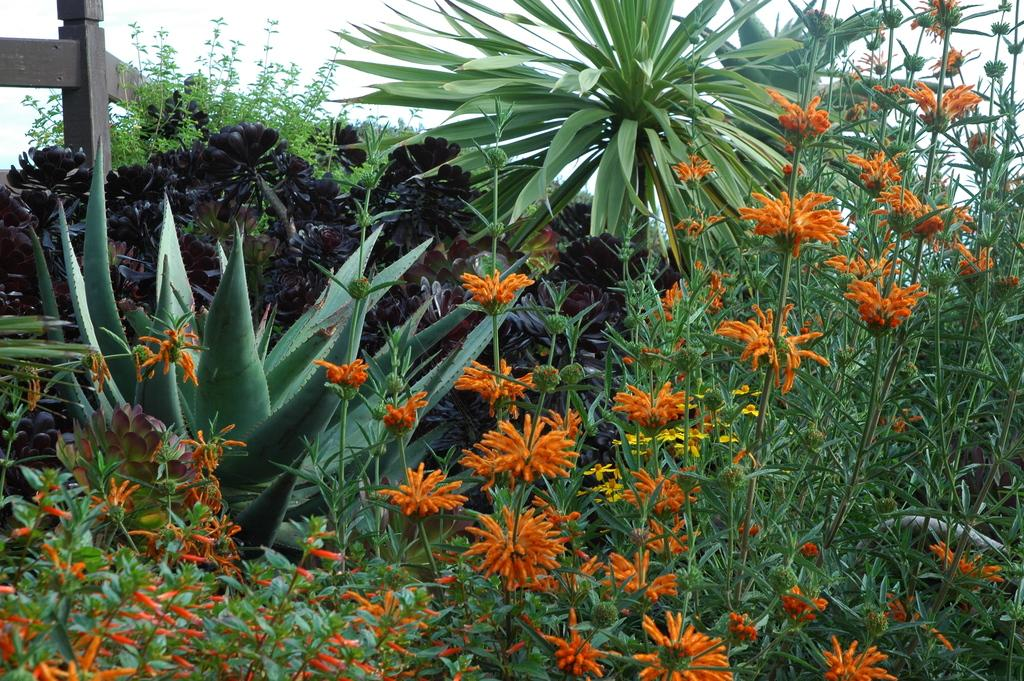What types of living organisms can be seen in the image? Plants and flowers are visible in the image. What type of structure is present in the image? There is a fence in the image. What can be seen in the background of the image? The sky is visible in the background of the image. What brand of toothpaste is advertised on the fence in the image? There is no toothpaste or advertisement present on the fence in the image. How many plates are stacked on the flowers in the image? There are no plates present in the image; it features plants, flowers, and a fence. 